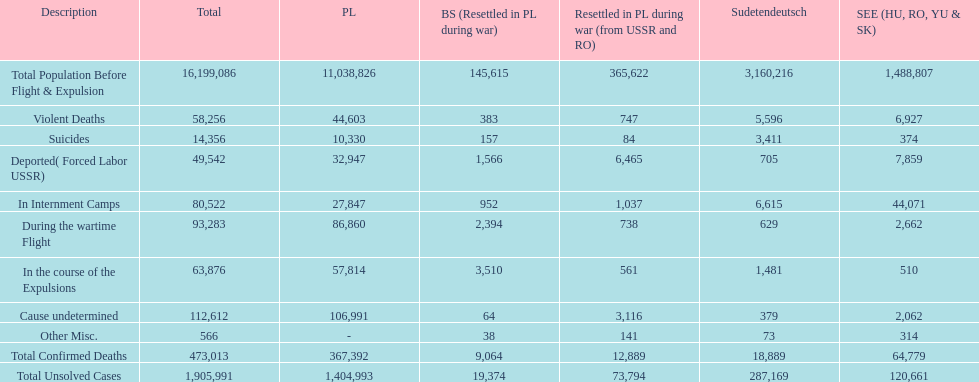How many causes were responsible for more than 50,000 confirmed deaths? 5. 